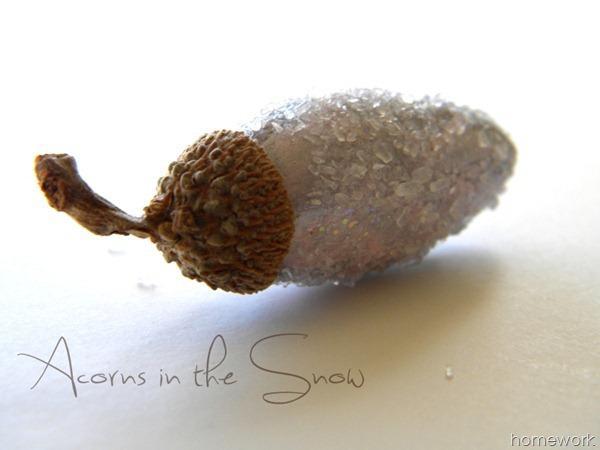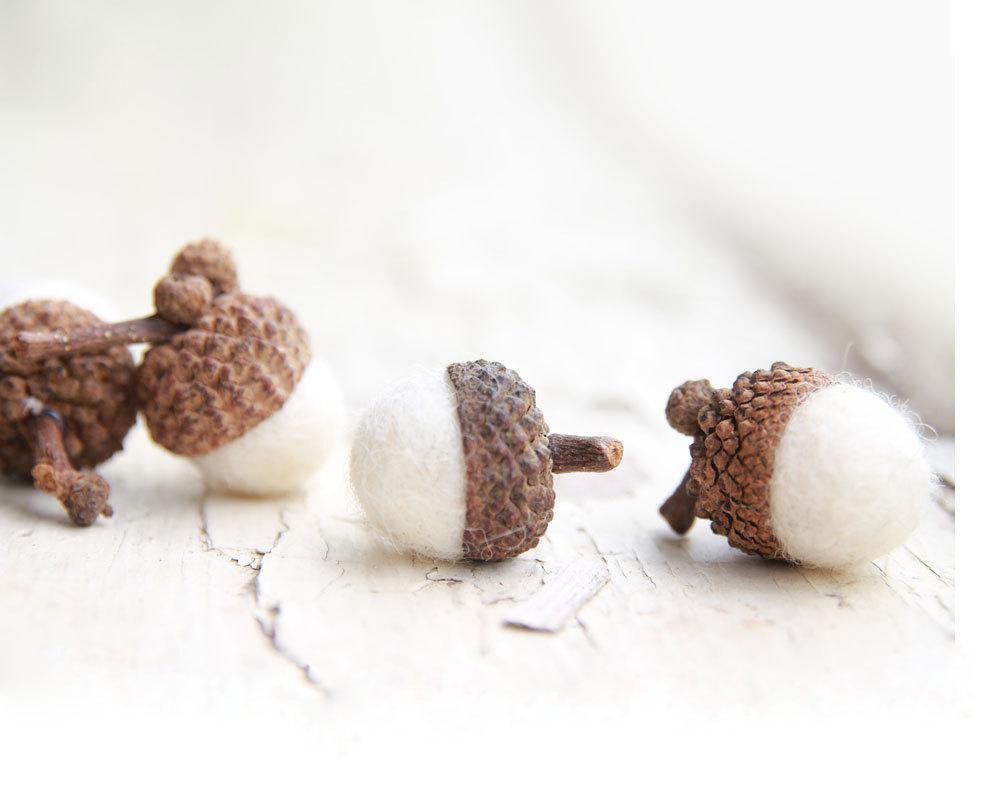The first image is the image on the left, the second image is the image on the right. Considering the images on both sides, is "The left and right image contains a total of five arons." valid? Answer yes or no. Yes. The first image is the image on the left, the second image is the image on the right. Analyze the images presented: Is the assertion "At least one image contains two real-looking side-by-side brown acorns with caps on." valid? Answer yes or no. No. 